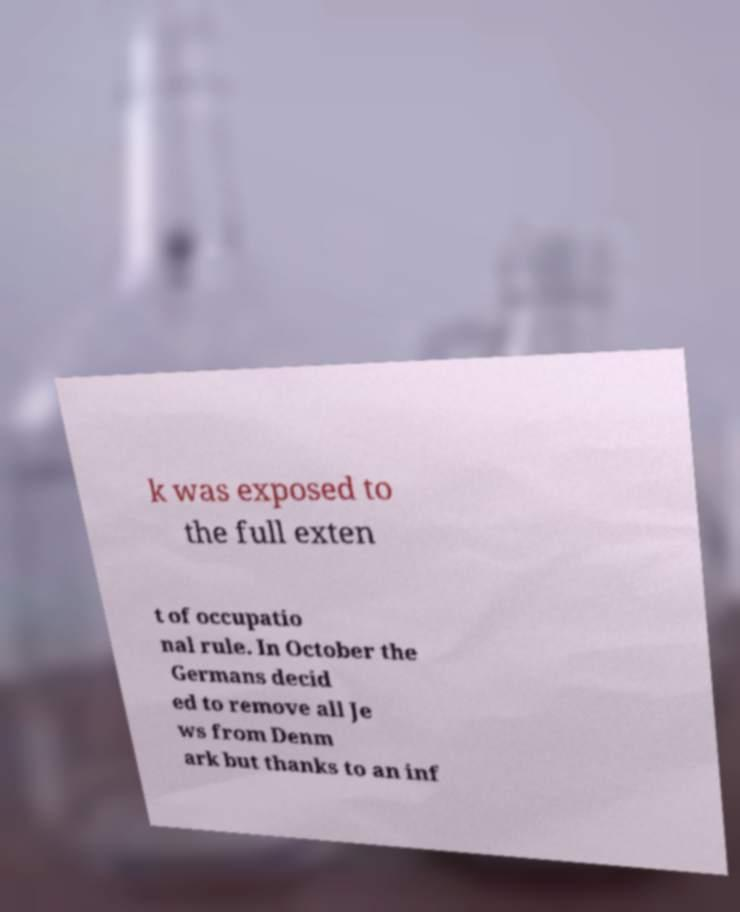Please read and relay the text visible in this image. What does it say? k was exposed to the full exten t of occupatio nal rule. In October the Germans decid ed to remove all Je ws from Denm ark but thanks to an inf 